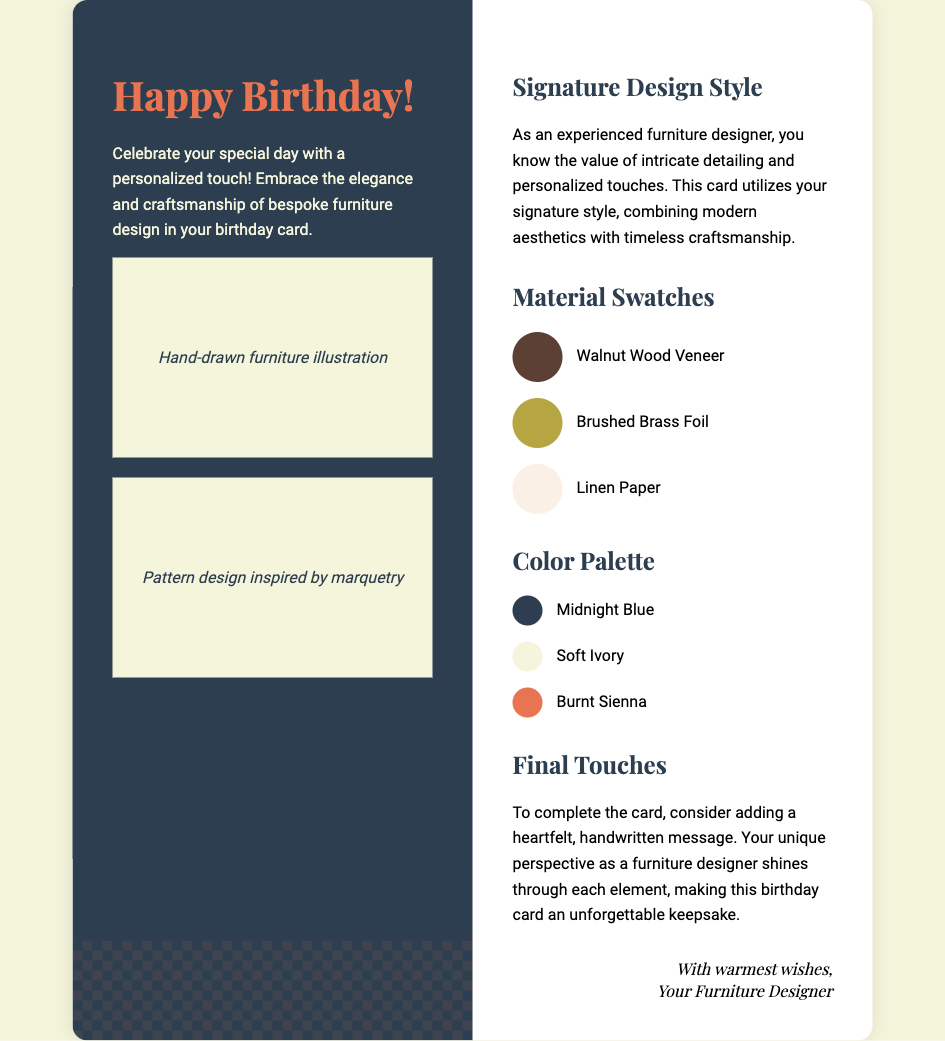What is the main purpose of the card? The card is designed to celebrate a birthday with a personalized touch, showcasing the elegance of bespoke furniture design.
Answer: Celebrate a birthday What color is the material swatch for Walnut Wood Veneer? The background color for Walnut Wood Veneer is specified in the card’s design.
Answer: #5c4033 How many color palette swatches are shown? The document lists the specific color swatches included in the color palette section of the card.
Answer: Three What design style does the card showcase? The card employs a signature design style that combines modern aesthetics with timeless craftsmanship.
Answer: Signature design style What type of illustrations are included? The illustrations mentioned in the card are specifically related to furniture design.
Answer: Hand-drawn furniture illustration What is suggested as a final touch for the card? The card includes a suggestion for a personalized element to make it more special.
Answer: Handwritten message What is the background color of the right panel? The right panel does not have a specific set color mentioned, though it is styled in a certain way in the document.
Answer: White Who is the sender of the card? The card ends with a signature indicating who is extending the birthday wishes.
Answer: Your Furniture Designer What is the title of the card? The title of the card is stated at the top of the left panel, indicating its main theme.
Answer: Happy Birthday! 